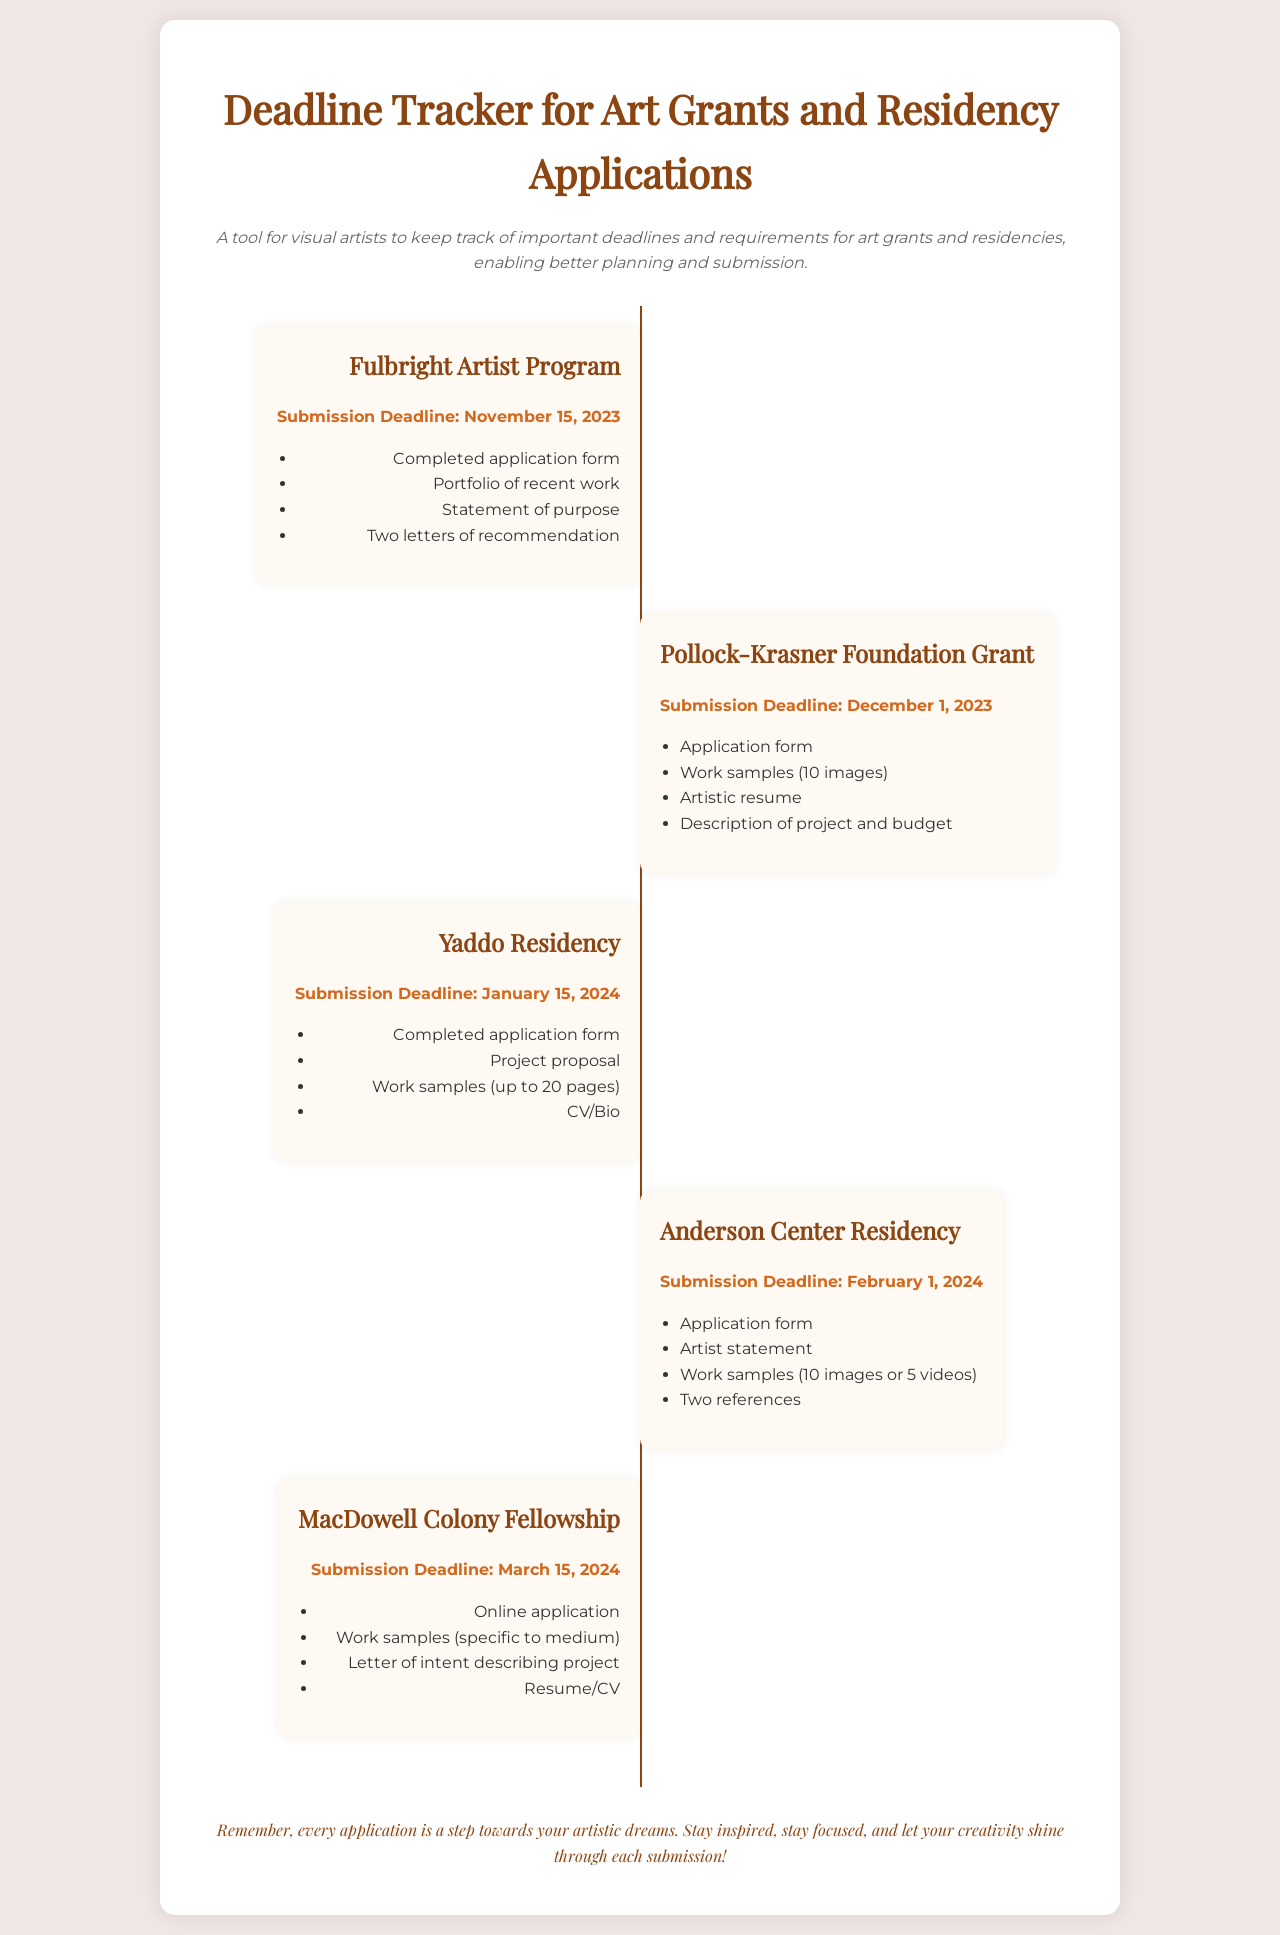What is the deadline for the Fulbright Artist Program? The deadline is clearly stated in the document under the Fulbright Artist Program entry.
Answer: November 15, 2023 How many work samples are required for the Pollock-Krasner Foundation Grant? The required number of work samples is mentioned in the requirements list for the Pollock-Krasner Foundation Grant.
Answer: 10 images What is one of the requirements for the Yaddo Residency? The requirements for the Yaddo Residency can be found in its entry.
Answer: Project proposal What is the submission deadline for the Anderson Center Residency? The deadline for the Anderson Center Residency is provided in the corresponding entry.
Answer: February 1, 2024 What is the last application deadline mentioned in the document? The last application deadline can be identified by checking the list of submission deadlines from the document entries.
Answer: March 15, 2024 How many letters of recommendation are needed for the Fulbright Artist Program? Specific requirements are listed for the Fulbright Artist Program entry, indicating the amount needed.
Answer: Two letters What is the theme of the encouragement message? The encouragement message conveys a general sentiment about the application process and artistic endeavors.
Answer: Stay inspired Which program requires an artist statement among its application requirements? By examining the entries, we can determine which application requires a specific document like an artist statement.
Answer: Anderson Center Residency 